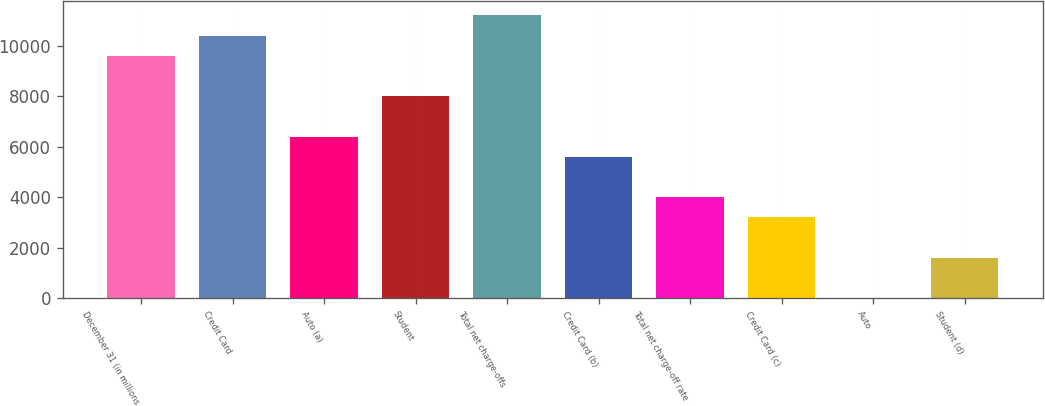Convert chart. <chart><loc_0><loc_0><loc_500><loc_500><bar_chart><fcel>December 31 (in millions<fcel>Credit Card<fcel>Auto (a)<fcel>Student<fcel>Total net charge-offs<fcel>Credit Card (b)<fcel>Total net charge-off rate<fcel>Credit Card (c)<fcel>Auto<fcel>Student (d)<nl><fcel>9610.61<fcel>10411.4<fcel>6407.45<fcel>8009.03<fcel>11212.2<fcel>5606.66<fcel>4005.08<fcel>3204.29<fcel>1.13<fcel>1602.71<nl></chart> 